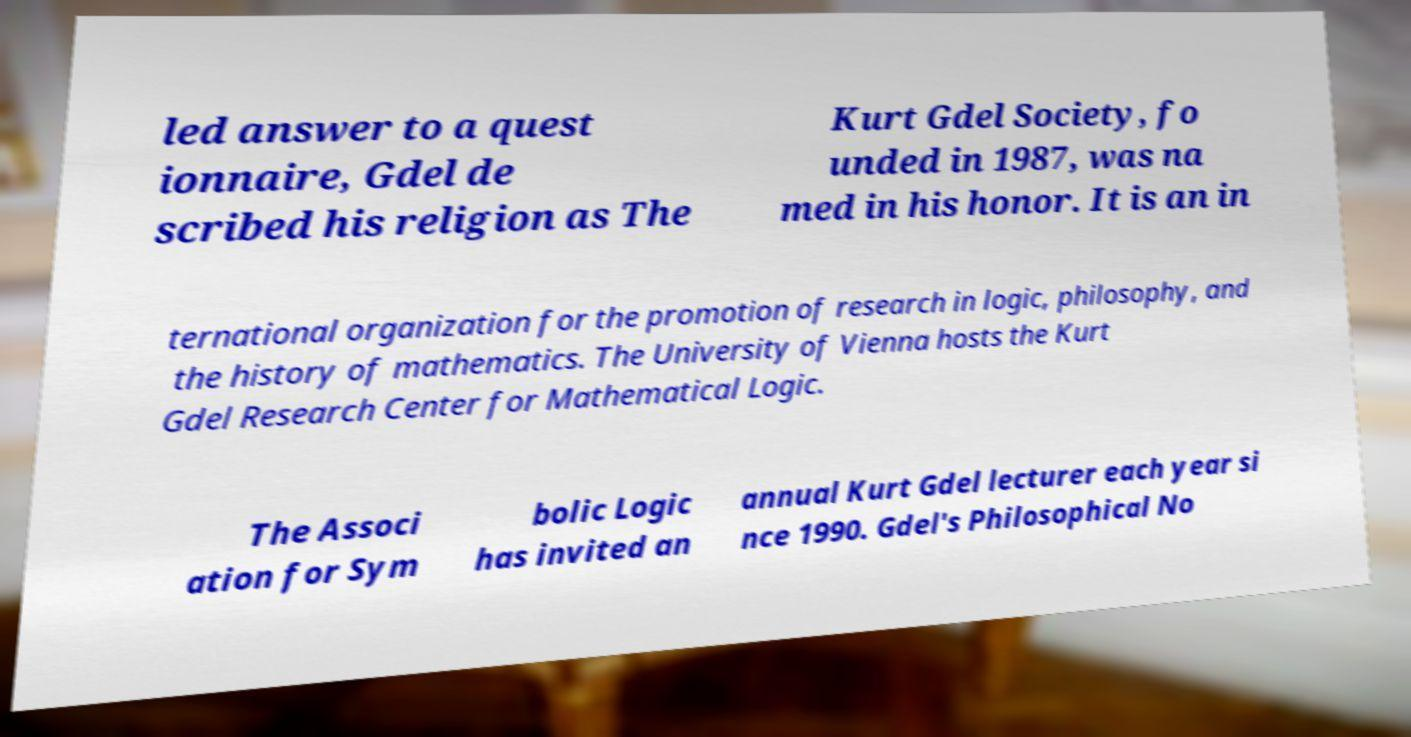Please identify and transcribe the text found in this image. led answer to a quest ionnaire, Gdel de scribed his religion as The Kurt Gdel Society, fo unded in 1987, was na med in his honor. It is an in ternational organization for the promotion of research in logic, philosophy, and the history of mathematics. The University of Vienna hosts the Kurt Gdel Research Center for Mathematical Logic. The Associ ation for Sym bolic Logic has invited an annual Kurt Gdel lecturer each year si nce 1990. Gdel's Philosophical No 